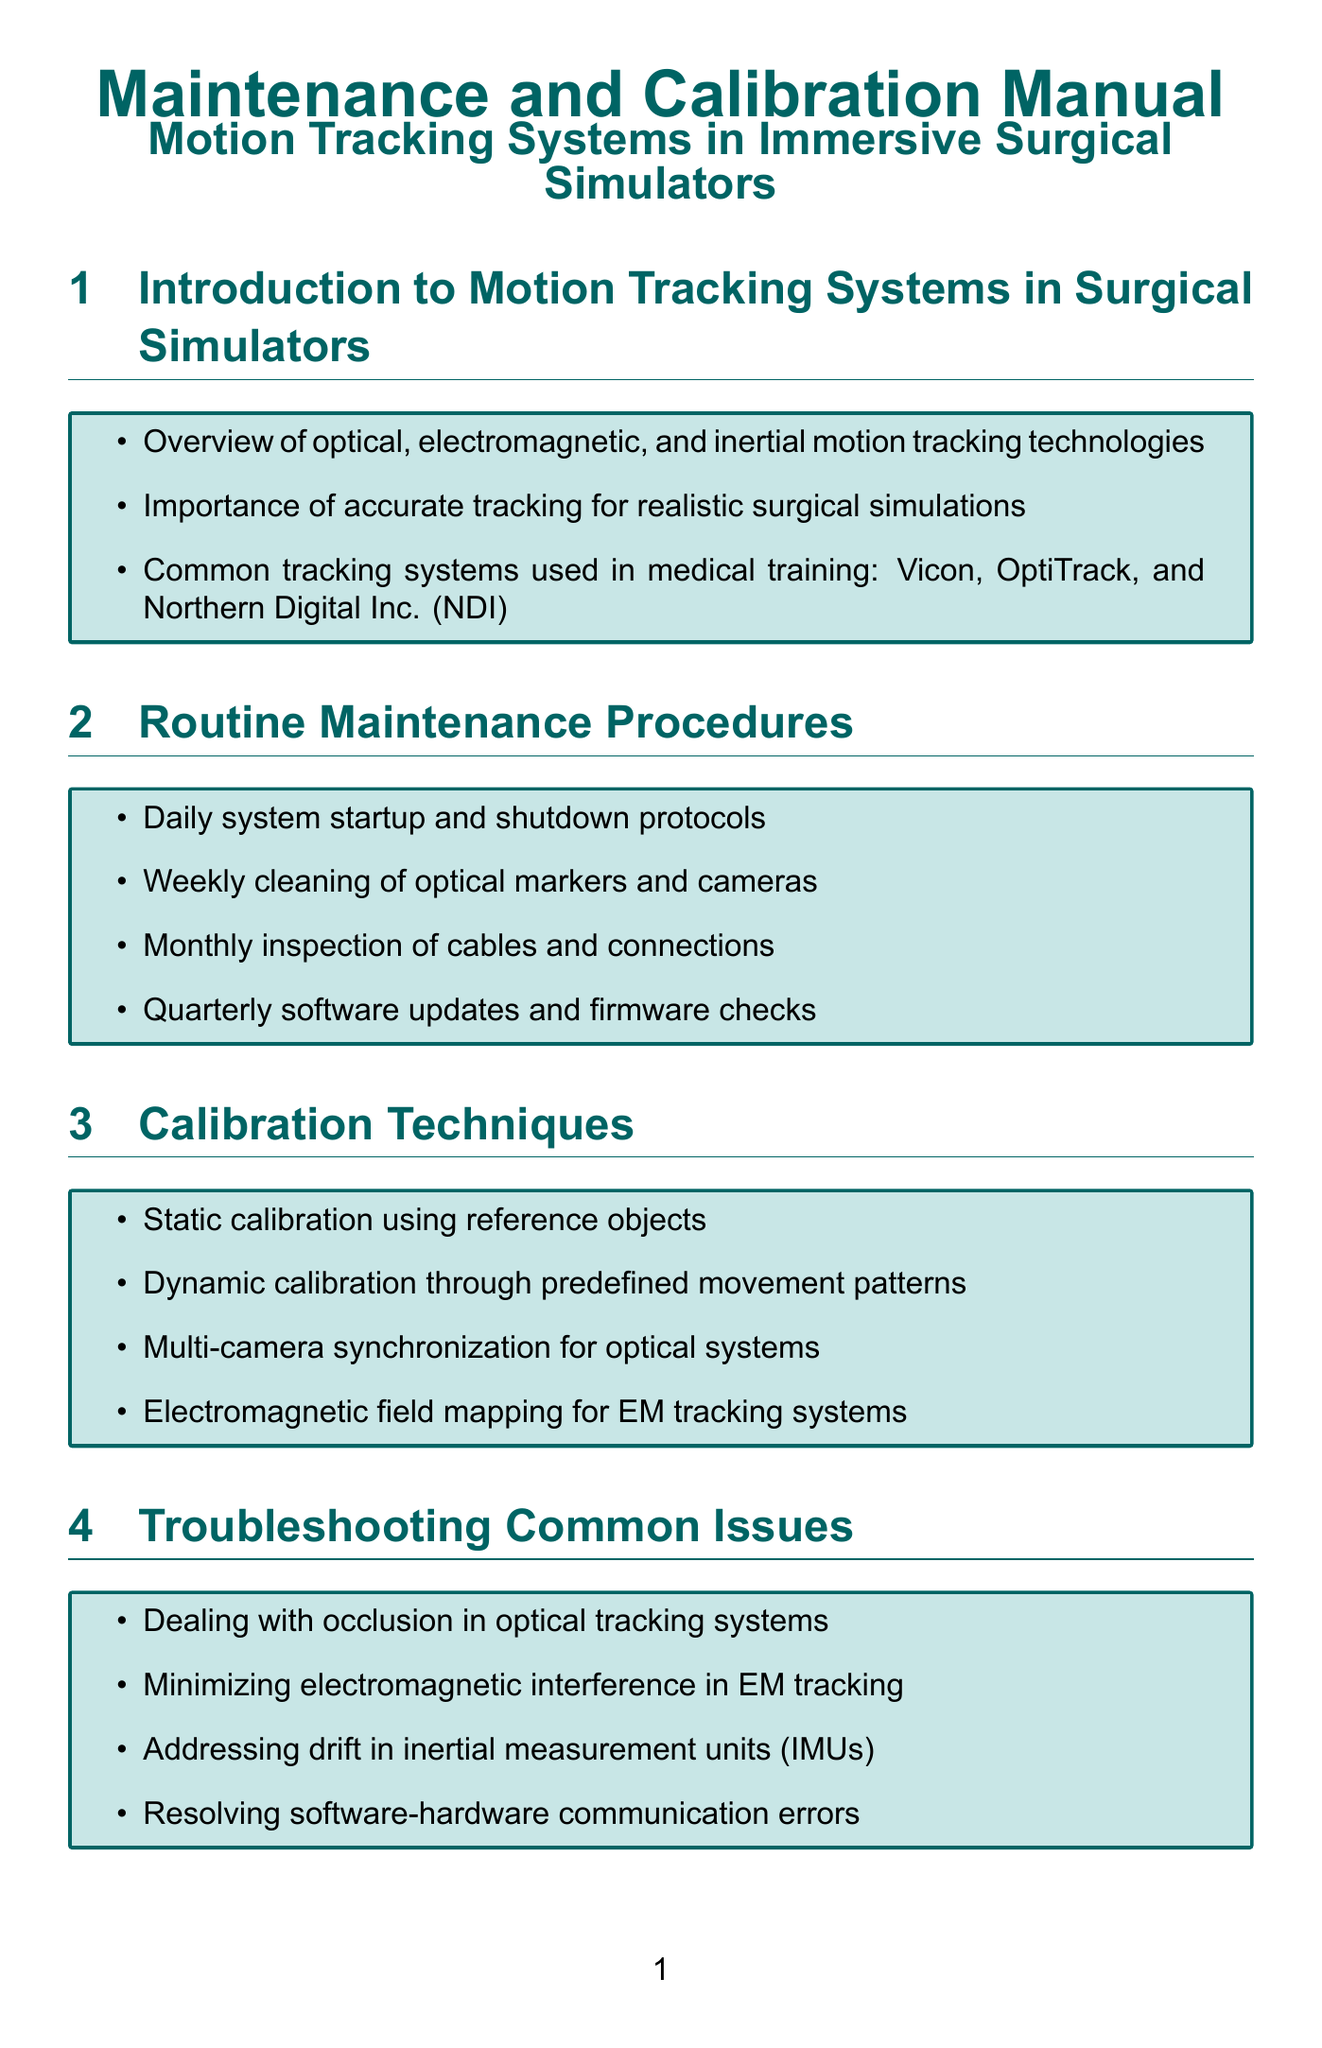What are the common tracking systems used in medical training? The document lists Vicon, OptiTrack, and Northern Digital Inc. (NDI) as common tracking systems for medical training.
Answer: Vicon, OptiTrack, NDI How often should optical markers and cameras be cleaned? According to the document, the cleaning of optical markers and cameras should occur weekly as part of the routine maintenance procedures.
Answer: Weekly What is a technique used for static calibration? The document mentions "static calibration using reference objects" as a calibration technique.
Answer: Static calibration using reference objects What issue can arise in optical tracking systems? The document notes "occlusion" as a common issue encountered in optical tracking systems.
Answer: Occlusion What is the minimum frequency for software updates? The document states that software updates and firmware checks should occur quarterly.
Answer: Quarterly Which standard must be adhered to for medical electrical equipment? The document specifies IEC 60601 as the standard to be adhered to for medical electrical equipment.
Answer: IEC 60601 What performance verification method uses high-speed cameras? The document describes "latency testing" as a performance verification method that utilizes high-speed cameras.
Answer: Latency testing What advanced topic involves custom algorithms? "Developing custom tracking algorithms for specific surgical procedures" is mentioned as an advanced topic for bioengineers in the document.
Answer: Custom tracking algorithms What is the purpose of maintaining calibration logs? The document states that maintaining calibration logs is necessary for FDA compliance.
Answer: FDA compliance 